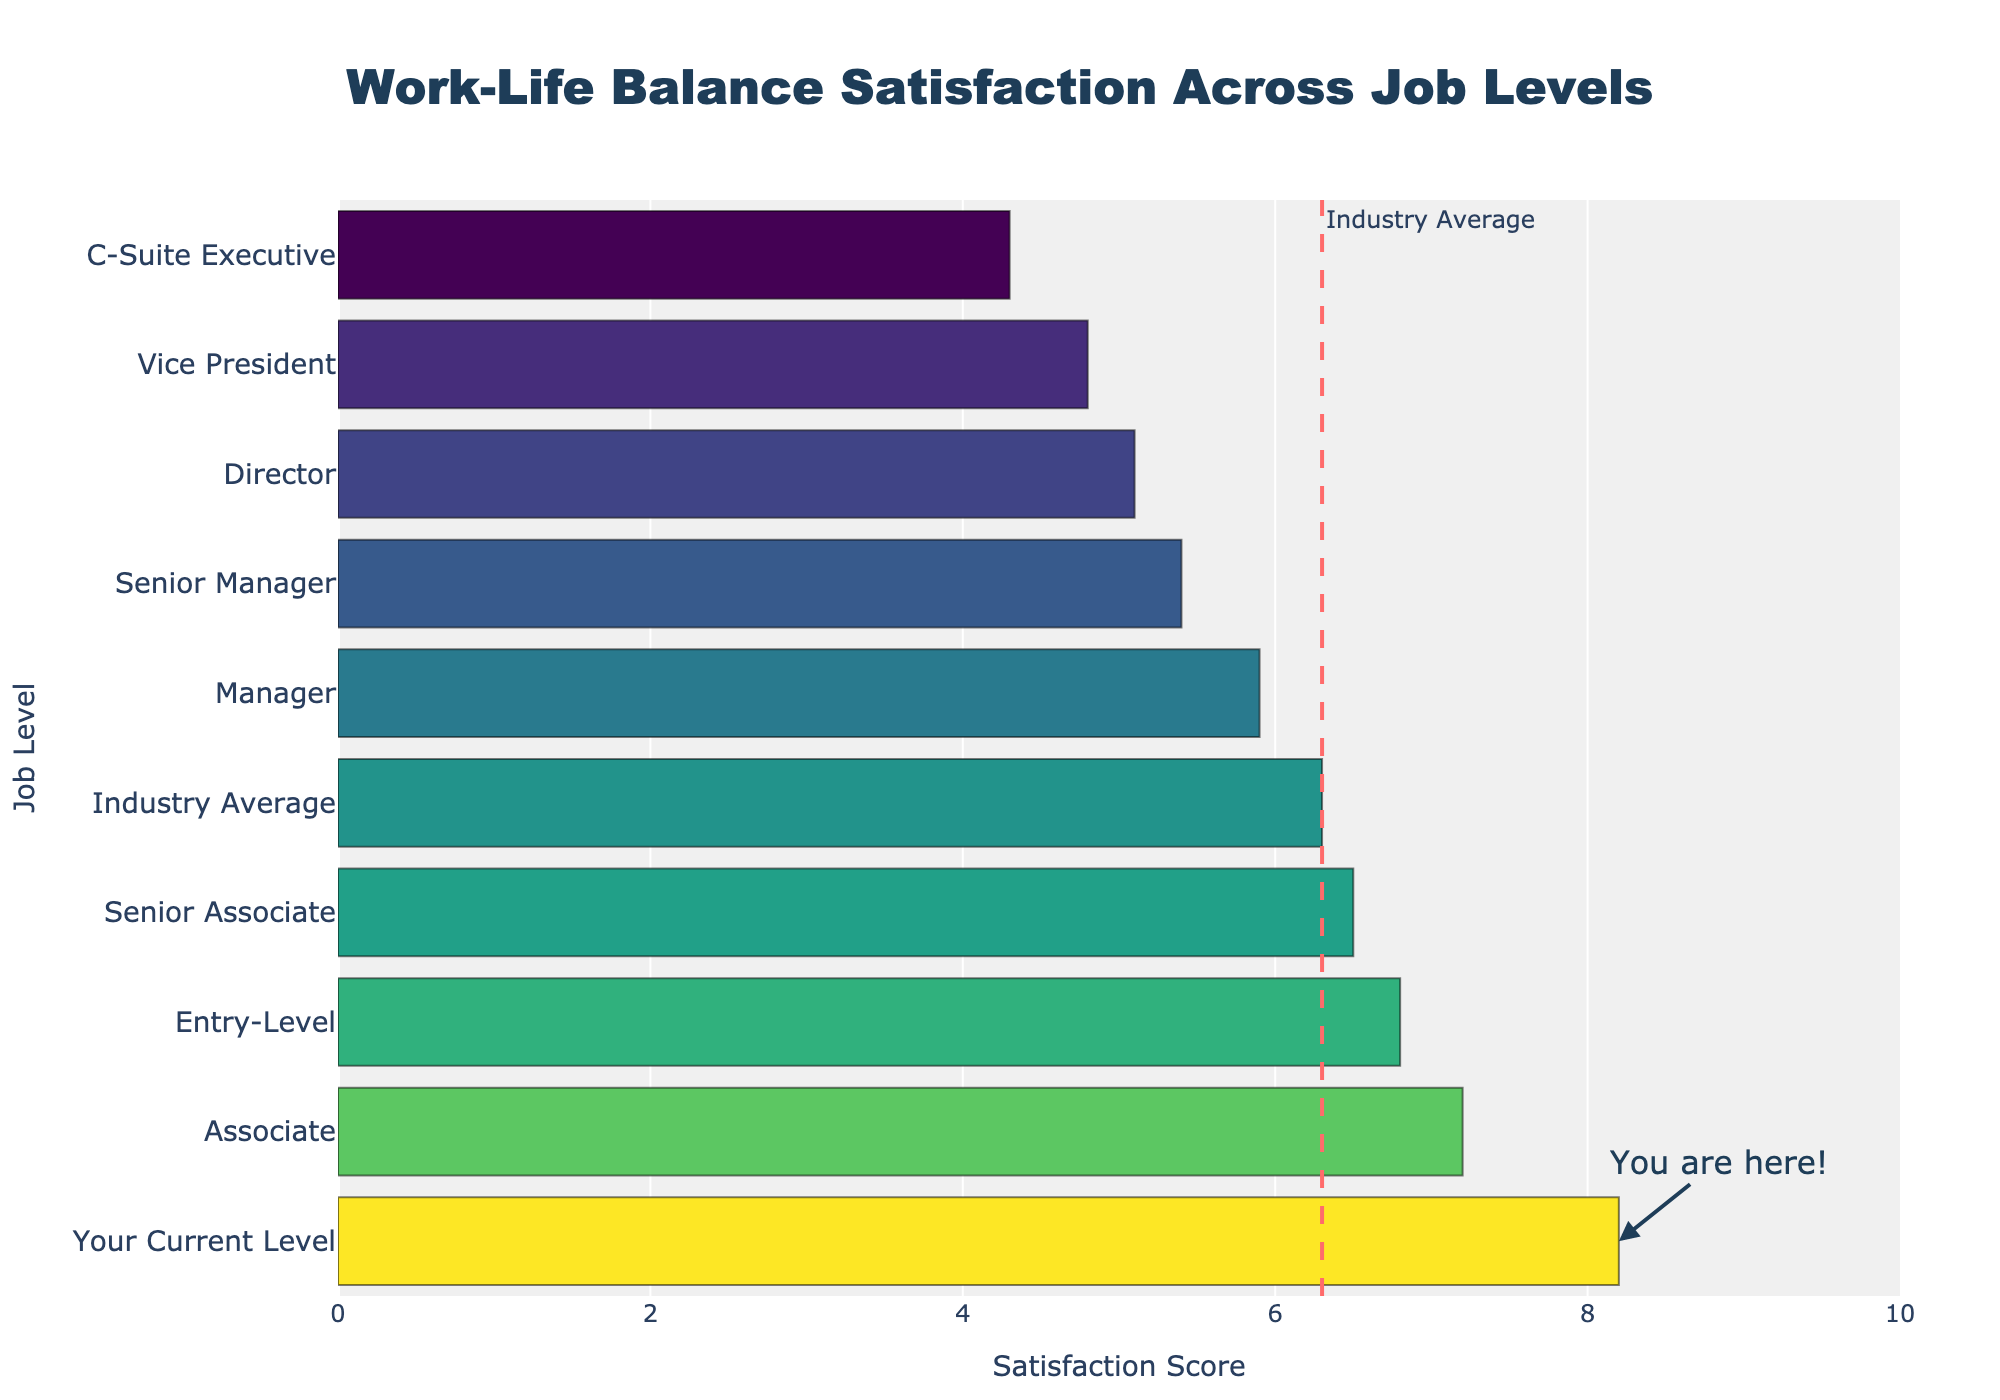Which job level has the highest work-life balance satisfaction score? According to the chart, "Your Current Level" has the highest work-life balance satisfaction score because its bar extends the farthest to the right.
Answer: Your Current Level How much higher is the satisfaction score for "Associate" compared to "Manager"? The satisfaction score for "Associate" is 7.2 and for "Manager" is 5.9. The difference is 7.2 - 5.9 = 1.3.
Answer: 1.3 What is the average work-life balance satisfaction score of "Senior Manager" and "Director"? The satisfaction score for "Senior Manager" is 5.4 and for "Director" is 5.1. The average is (5.4 + 5.1) / 2 = 5.25.
Answer: 5.25 Which job level is closest to the industry average satisfaction score? The bar for "Senior Associate" at 6.5 is closest to the industry average of 6.3. Since 6.3 and 6.5 are both close in value, "Senior Associate" is closest.
Answer: Senior Associate Which job level has the lowest work-life balance satisfaction score? The bar for "C-Suite Executive" is the shortest, indicating the lowest satisfaction score of 4.3.
Answer: C-Suite Executive How many job levels have a satisfaction score above the industry average? The industry average is 6.3. By observing the bars, Entry-Level, Associate, and Your Current Level all have scores above 6.3. Thus, there are 3 job levels above industry average.
Answer: 3 What is the range of work-life balance satisfaction scores across job levels? The highest score is Your Current Level at 8.2, and the lowest is C-Suite Executive at 4.3. The range is 8.2 - 4.3 = 3.9.
Answer: 3.9 Is the satisfaction score of "Manager" greater than the industry average? The satisfaction score of "Manager" is 5.9, which is less than the industry average of 6.3.
Answer: No Compare the work-life balance satisfaction scores of "Senior Associate" and "Vice President". Which is higher? The score for "Senior Associate" is 6.5, while "Vice President" has a score of 4.8. Thus, "Senior Associate" has the higher satisfaction score.
Answer: Senior Associate By how much does the satisfaction score for "Your Current Level" exceed the satisfaction score of the "C-Suite Executive"? The satisfaction score for "Your Current Level" is 8.2 and for "C-Suite Executive" it is 4.3. The difference is 8.2 - 4.3 = 3.9.
Answer: 3.9 